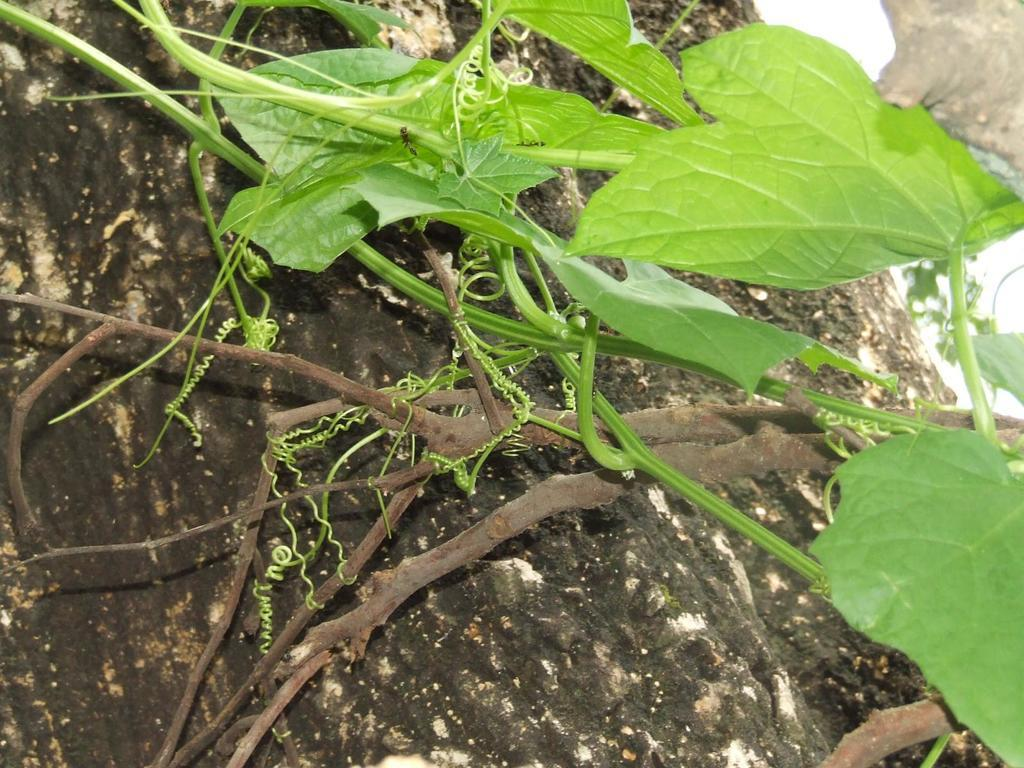What type of plant material is present on the surface in the image? There are leaves and stems on a surface in the image. Can you describe the object visible in the background of the image? Unfortunately, the provided facts do not give any information about the object in the background. What language is being spoken in the image? There is no information about any language being spoken in the image. 